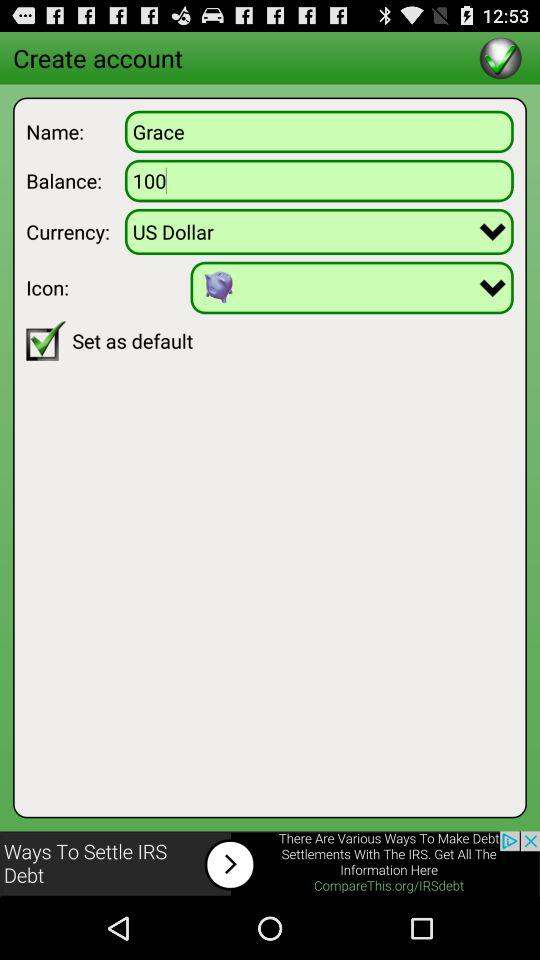What's the currency? The currency is "US Dollar". 